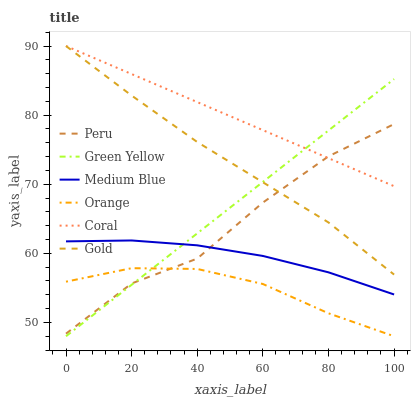Does Orange have the minimum area under the curve?
Answer yes or no. Yes. Does Coral have the maximum area under the curve?
Answer yes or no. Yes. Does Medium Blue have the minimum area under the curve?
Answer yes or no. No. Does Medium Blue have the maximum area under the curve?
Answer yes or no. No. Is Green Yellow the smoothest?
Answer yes or no. Yes. Is Peru the roughest?
Answer yes or no. Yes. Is Coral the smoothest?
Answer yes or no. No. Is Coral the roughest?
Answer yes or no. No. Does Medium Blue have the lowest value?
Answer yes or no. No. Does Coral have the highest value?
Answer yes or no. Yes. Does Medium Blue have the highest value?
Answer yes or no. No. Is Orange less than Coral?
Answer yes or no. Yes. Is Coral greater than Medium Blue?
Answer yes or no. Yes. Does Peru intersect Green Yellow?
Answer yes or no. Yes. Is Peru less than Green Yellow?
Answer yes or no. No. Is Peru greater than Green Yellow?
Answer yes or no. No. Does Orange intersect Coral?
Answer yes or no. No. 